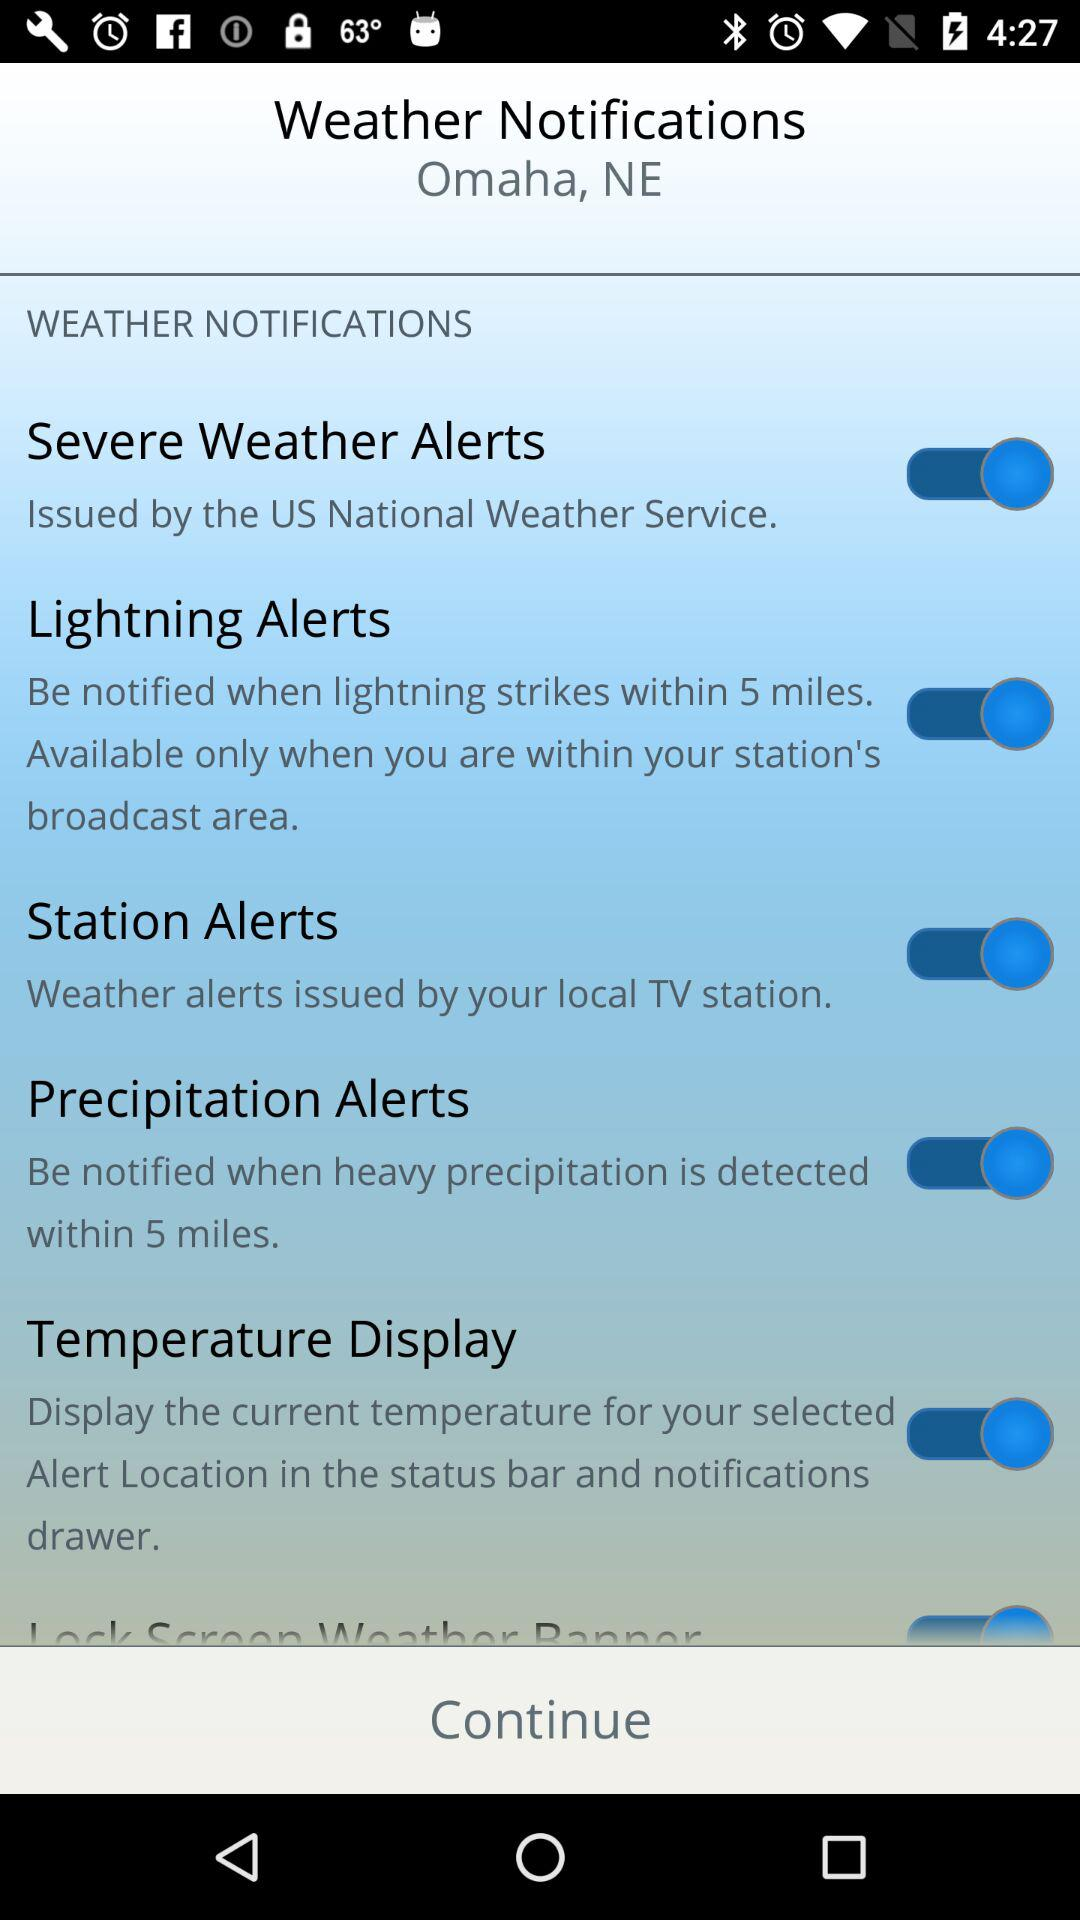What is the status of "Temperature Display"? The status is "on". 